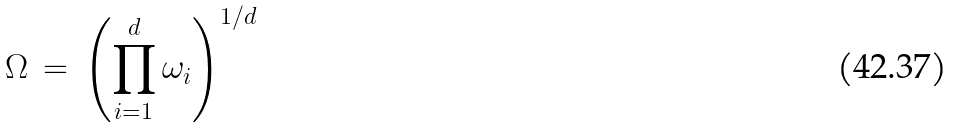<formula> <loc_0><loc_0><loc_500><loc_500>\Omega \, = \, \left ( \prod _ { i = 1 } ^ { d } \omega _ { i } \right ) ^ { 1 / d }</formula> 